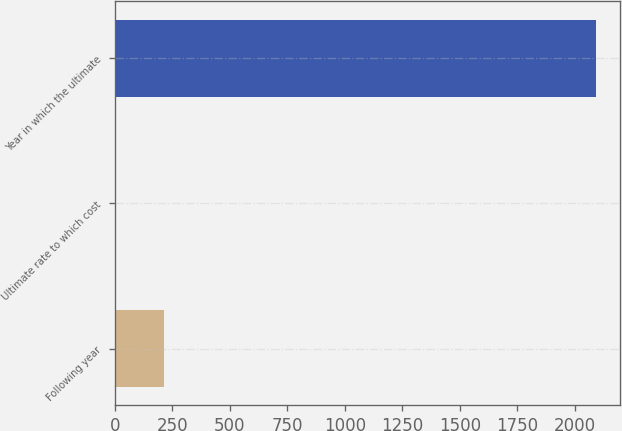<chart> <loc_0><loc_0><loc_500><loc_500><bar_chart><fcel>Following year<fcel>Ultimate rate to which cost<fcel>Year in which the ultimate<nl><fcel>213.36<fcel>4.4<fcel>2094<nl></chart> 